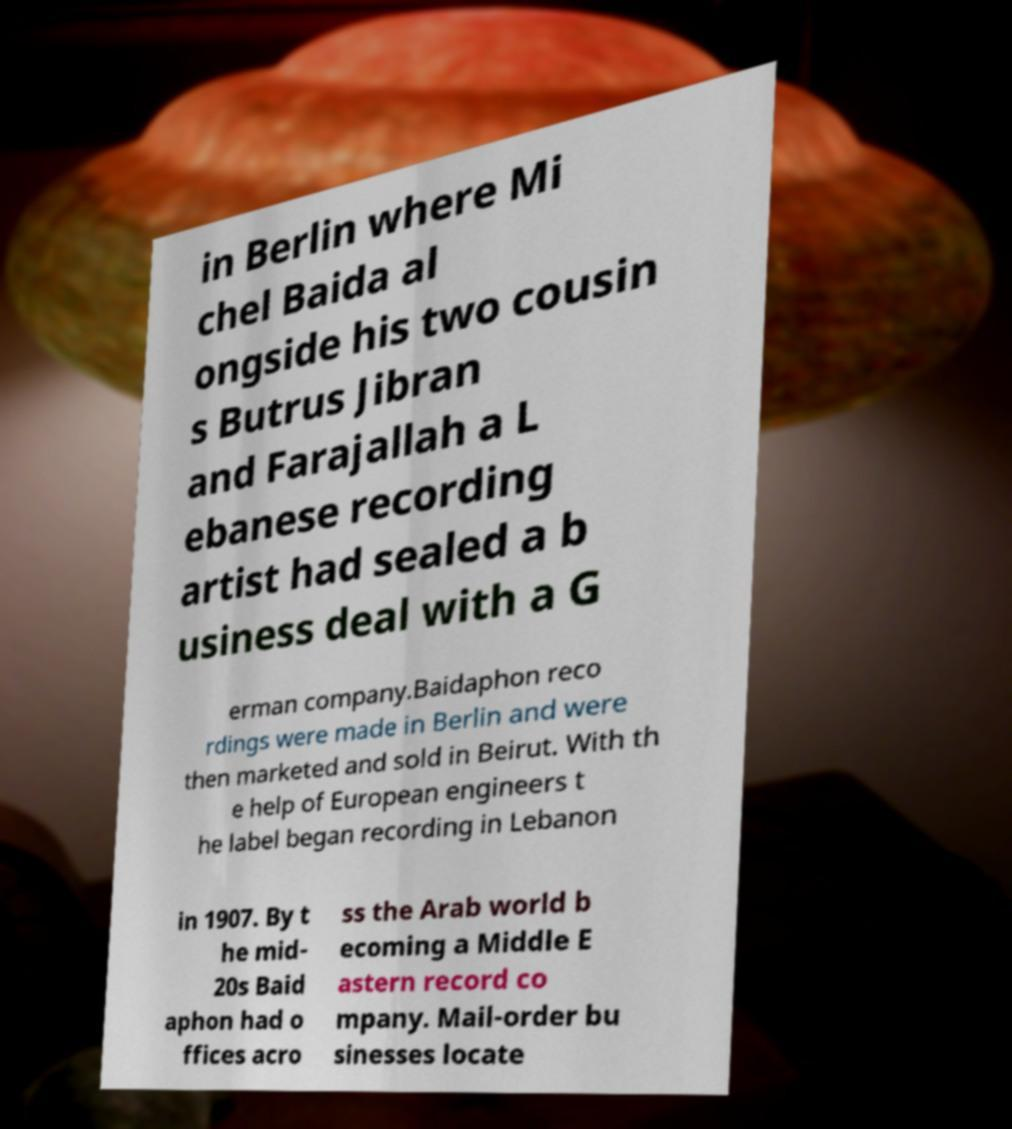Can you accurately transcribe the text from the provided image for me? in Berlin where Mi chel Baida al ongside his two cousin s Butrus Jibran and Farajallah a L ebanese recording artist had sealed a b usiness deal with a G erman company.Baidaphon reco rdings were made in Berlin and were then marketed and sold in Beirut. With th e help of European engineers t he label began recording in Lebanon in 1907. By t he mid- 20s Baid aphon had o ffices acro ss the Arab world b ecoming a Middle E astern record co mpany. Mail-order bu sinesses locate 